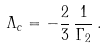<formula> <loc_0><loc_0><loc_500><loc_500>\Lambda _ { c } = - \frac { 2 } { 3 } \, \frac { 1 } { \Gamma _ { 2 } } \, .</formula> 